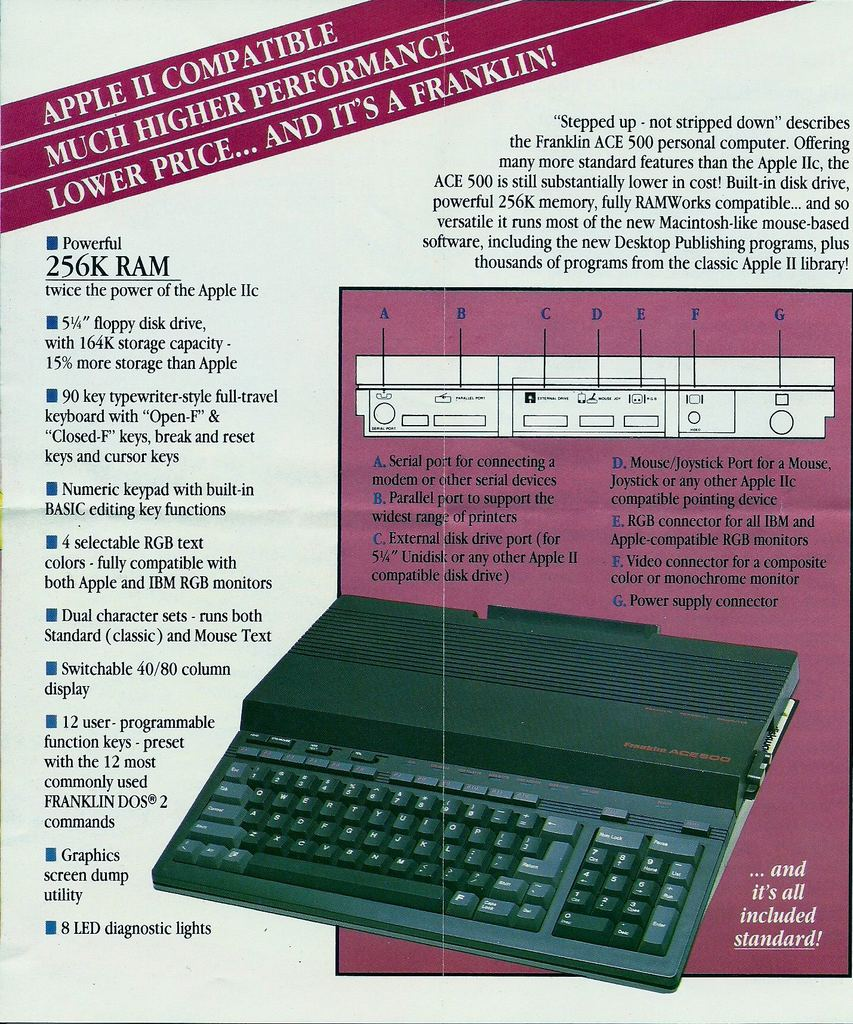Provide a one-sentence caption for the provided image.
Reference OCR token: APPLE, II, COMP, MPATIBLE, PERFORMANCE, A, FRANKLIN!, HIGHER, PRICE..., AND, IT'S, MUCH, "Stepped, strippd, describes, many, AppleII, ACE, powerfu, 256K, versatile, othe, Powerful, Publishing, 256K, RAM, thousands, programs, hepowee, ApplelIc, with, keytypewriter-style, full-travel, keyboard, "Closed-F, PortrMo, Numeric, withbuilt, pointing, editine, functions, ofprinters, IBMand, selectable, compatible, Bmonitors, Unidisk, compatible, monochrom, Powersupply, connector, character, runboth, Text, Switchable, column, programmable, withthe, commonly, Graphics, screen, and, it'sall, included, lights, standard! The image is an advertisement for the Franklin ACE 500 computer, highlighting its Apple II compatibility, powerful 256K RAM, and a host of features like a full-travel keyboard, RGB text display compatibility, and dual character sets, all at a lower price point than the Apple IIc. 